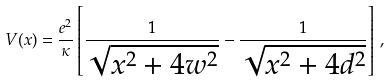<formula> <loc_0><loc_0><loc_500><loc_500>V ( x ) = \frac { e ^ { 2 } } { \kappa } \left [ \frac { 1 } { \sqrt { x ^ { 2 } + 4 w ^ { 2 } } } - \frac { 1 } { \sqrt { x ^ { 2 } + 4 d ^ { 2 } } } \right ] \, ,</formula> 